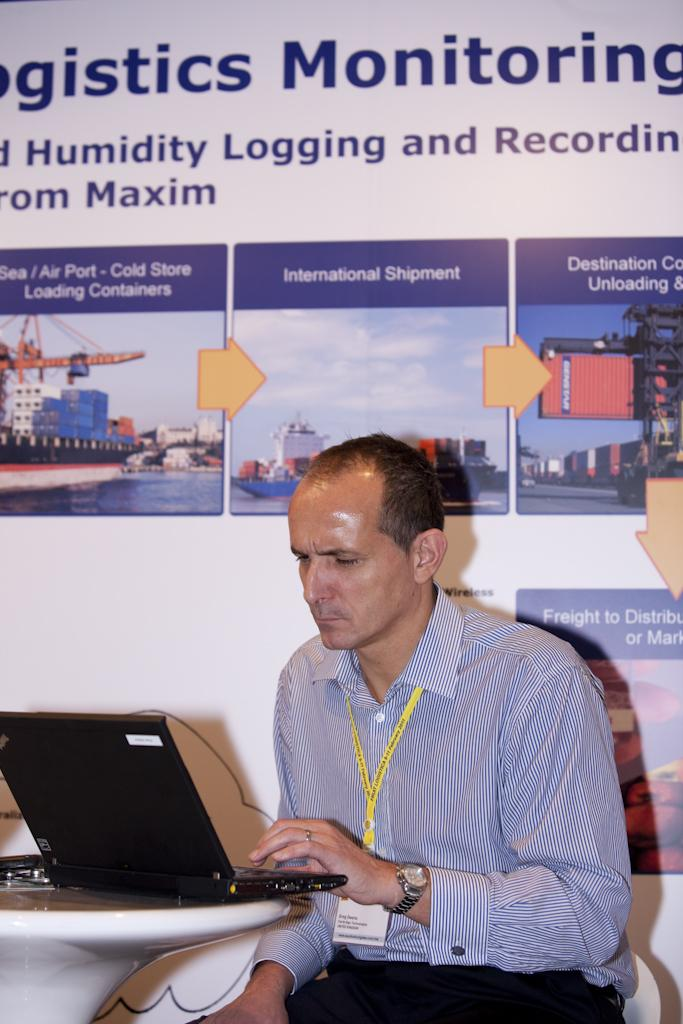What is the main subject in the center of the image? There is a man sitting in the center of the image. What is in front of the man? There is a table in front of the man. What object is placed on the table? A laptop is placed on the table. What can be seen on the wall in the background? There is a board placed on the wall in the background. How many icicles are hanging from the man's hair in the image? There are no icicles present in the image; the man's hair is not shown to be hanging with icicles. 